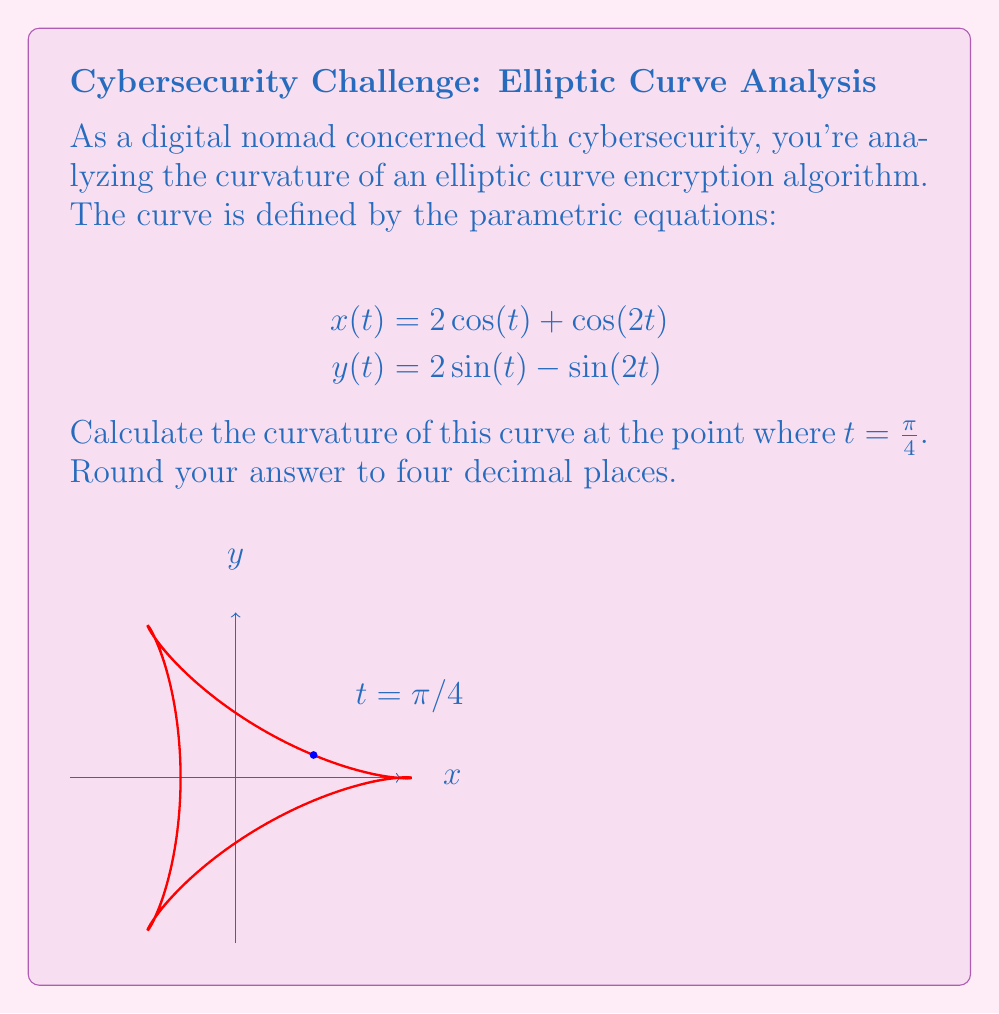Can you answer this question? To find the curvature, we'll use the formula:

$$\kappa = \frac{|x'y'' - y'x''|}{(x'^2 + y'^2)^{3/2}}$$

Step 1: Calculate the first derivatives
$$x'(t) = -2\sin(t) - 2\sin(2t)$$
$$y'(t) = 2\cos(t) - 2\cos(2t)$$

Step 2: Calculate the second derivatives
$$x''(t) = -2\cos(t) - 4\cos(2t)$$
$$y''(t) = -2\sin(t) + 4\sin(2t)$$

Step 3: Evaluate the derivatives at $t = \frac{\pi}{4}$
$$x'(\frac{\pi}{4}) = -2\sin(\frac{\pi}{4}) - 2\sin(\frac{\pi}{2}) = -\sqrt{2} - 2$$
$$y'(\frac{\pi}{4}) = 2\cos(\frac{\pi}{4}) - 2\cos(\frac{\pi}{2}) = \sqrt{2}$$
$$x''(\frac{\pi}{4}) = -2\cos(\frac{\pi}{4}) - 4\cos(\frac{\pi}{2}) = -\sqrt{2}$$
$$y''(\frac{\pi}{4}) = -2\sin(\frac{\pi}{4}) + 4\sin(\frac{\pi}{2}) = -\sqrt{2} + 4$$

Step 4: Calculate the numerator of the curvature formula
$$|x'y'' - y'x''| = |(-\sqrt{2} - 2)(-\sqrt{2} + 4) - \sqrt{2}(-\sqrt{2})|$$
$$= |(2\sqrt{2} + 4 - 4\sqrt{2} - 8) + 2| = |-2\sqrt{2} - 2| = 2\sqrt{2} + 2$$

Step 5: Calculate the denominator of the curvature formula
$$(x'^2 + y'^2)^{3/2} = ((-\sqrt{2} - 2)^2 + (\sqrt{2})^2)^{3/2}$$
$$= (4 + 4\sqrt{2} + 4 + 2)^{3/2} = (10 + 4\sqrt{2})^{3/2}$$

Step 6: Compute the final curvature
$$\kappa = \frac{2\sqrt{2} + 2}{(10 + 4\sqrt{2})^{3/2}} \approx 0.2679$$
Answer: 0.2679 